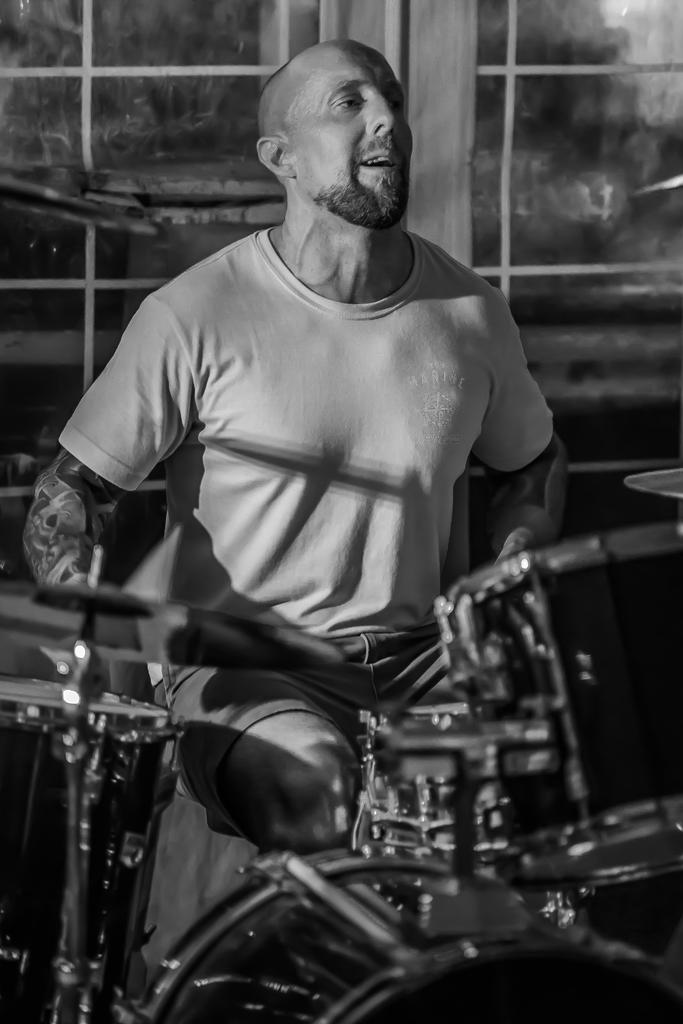What is the main subject of the image? There is a man standing in the image. What else can be seen in the image besides the man? There are musical instruments in the image. What can be seen in the background of the image? There are windows visible in the background of the image. What type of government is being discussed in the image? There is no discussion of government in the image; it features a man standing and musical instruments. How many bites can be seen being taken out of the musical instruments in the image? There are no bites taken out of the musical instruments in the image; they are intact. 